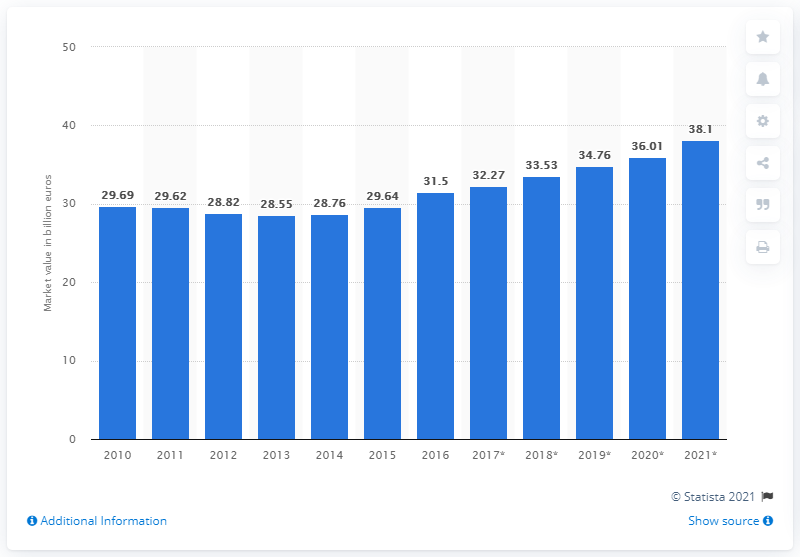Indicate a few pertinent items in this graphic. The estimated value of the Italian entertainment and media market is projected to be 38.1 billion euros by 2021. In 2011, the Italian entertainment and media market was valued at 29.64 billion U.S. dollars. 